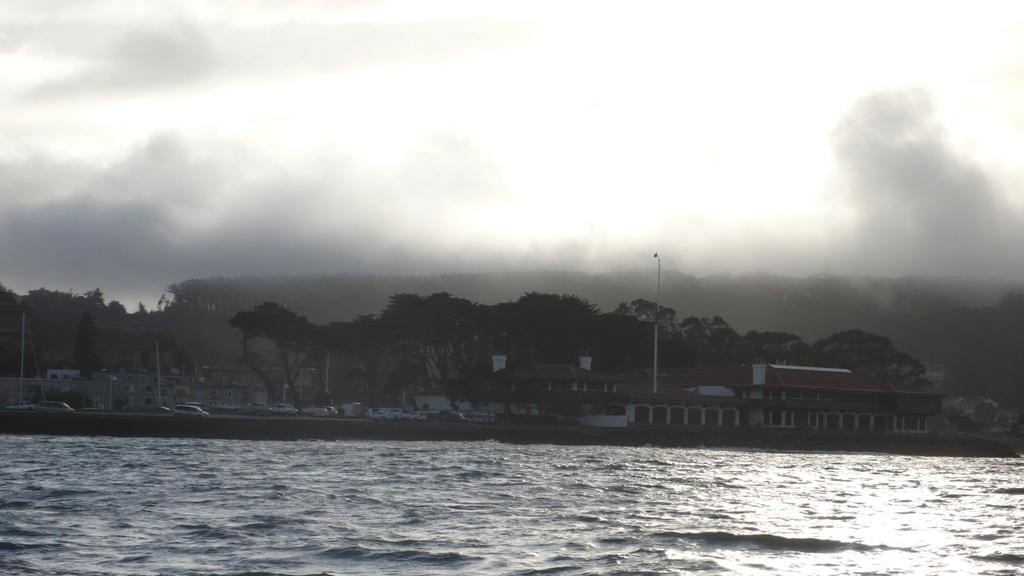What is the color scheme of the image? The image is black and white. What is the main feature in the foreground of the image? There is a water surface in the foreground of the image. What can be seen in the background of the image? In the background of the image, there are cars on a road, trees, buildings, and the sky. Can you see any wool in the image? There is no wool present in the image. Is it raining in the image? The image does not show any rain or indication of rain. 